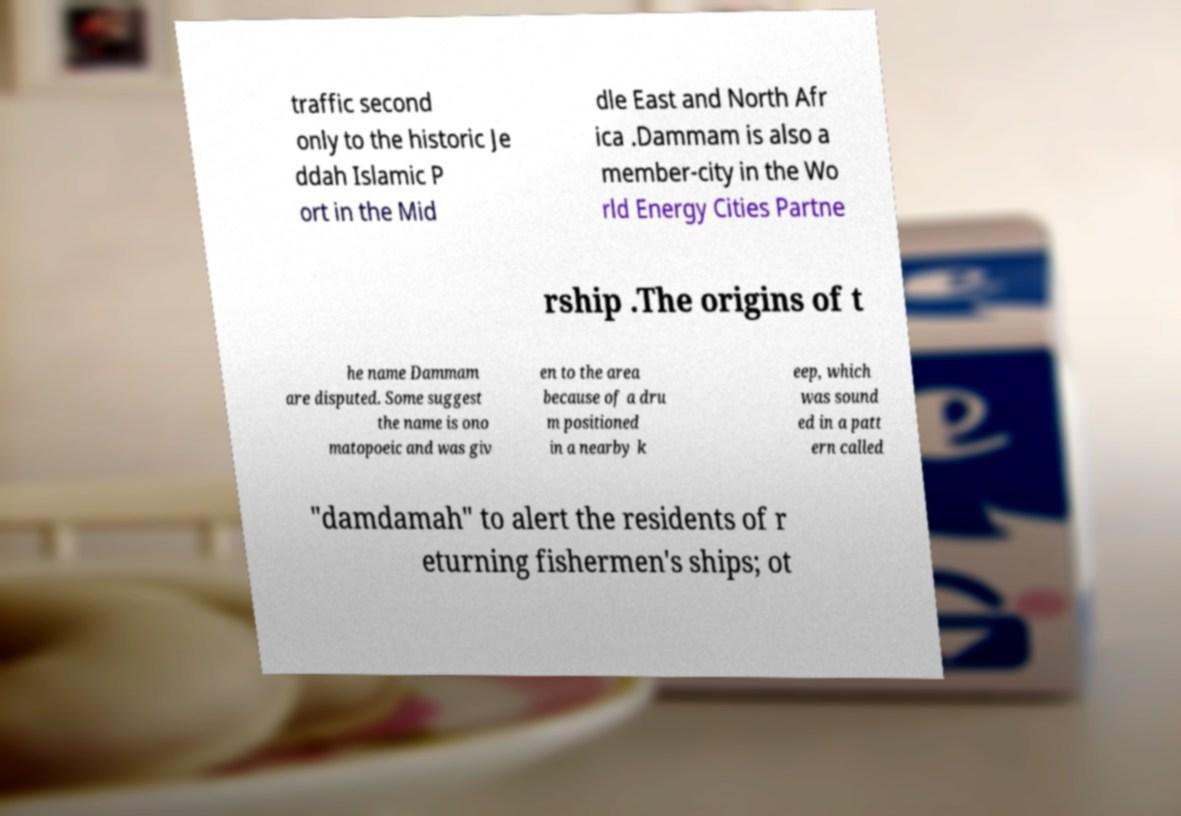Could you extract and type out the text from this image? traffic second only to the historic Je ddah Islamic P ort in the Mid dle East and North Afr ica .Dammam is also a member-city in the Wo rld Energy Cities Partne rship .The origins of t he name Dammam are disputed. Some suggest the name is ono matopoeic and was giv en to the area because of a dru m positioned in a nearby k eep, which was sound ed in a patt ern called "damdamah" to alert the residents of r eturning fishermen's ships; ot 